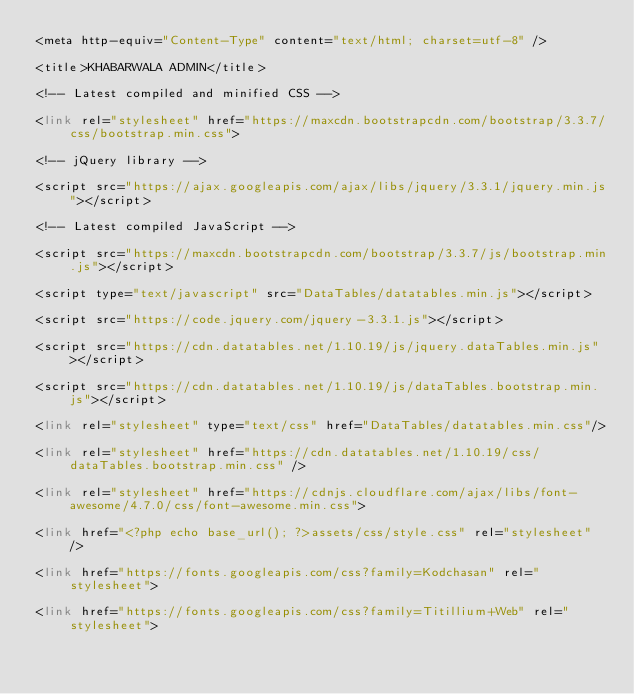Convert code to text. <code><loc_0><loc_0><loc_500><loc_500><_PHP_><meta http-equiv="Content-Type" content="text/html; charset=utf-8" />
<title>KHABARWALA ADMIN</title>
<!-- Latest compiled and minified CSS -->
<link rel="stylesheet" href="https://maxcdn.bootstrapcdn.com/bootstrap/3.3.7/css/bootstrap.min.css">
<!-- jQuery library -->
<script src="https://ajax.googleapis.com/ajax/libs/jquery/3.3.1/jquery.min.js"></script>
<!-- Latest compiled JavaScript -->
<script src="https://maxcdn.bootstrapcdn.com/bootstrap/3.3.7/js/bootstrap.min.js"></script>
<script type="text/javascript" src="DataTables/datatables.min.js"></script>
<script src="https://code.jquery.com/jquery-3.3.1.js"></script>
<script src="https://cdn.datatables.net/1.10.19/js/jquery.dataTables.min.js"></script>
<script src="https://cdn.datatables.net/1.10.19/js/dataTables.bootstrap.min.js"></script>
<link rel="stylesheet" type="text/css" href="DataTables/datatables.min.css"/>
<link rel="stylesheet" href="https://cdn.datatables.net/1.10.19/css/dataTables.bootstrap.min.css" />
<link rel="stylesheet" href="https://cdnjs.cloudflare.com/ajax/libs/font-awesome/4.7.0/css/font-awesome.min.css">
<link href="<?php echo base_url(); ?>assets/css/style.css" rel="stylesheet" />
<link href="https://fonts.googleapis.com/css?family=Kodchasan" rel="stylesheet">
<link href="https://fonts.googleapis.com/css?family=Titillium+Web" rel="stylesheet"></code> 